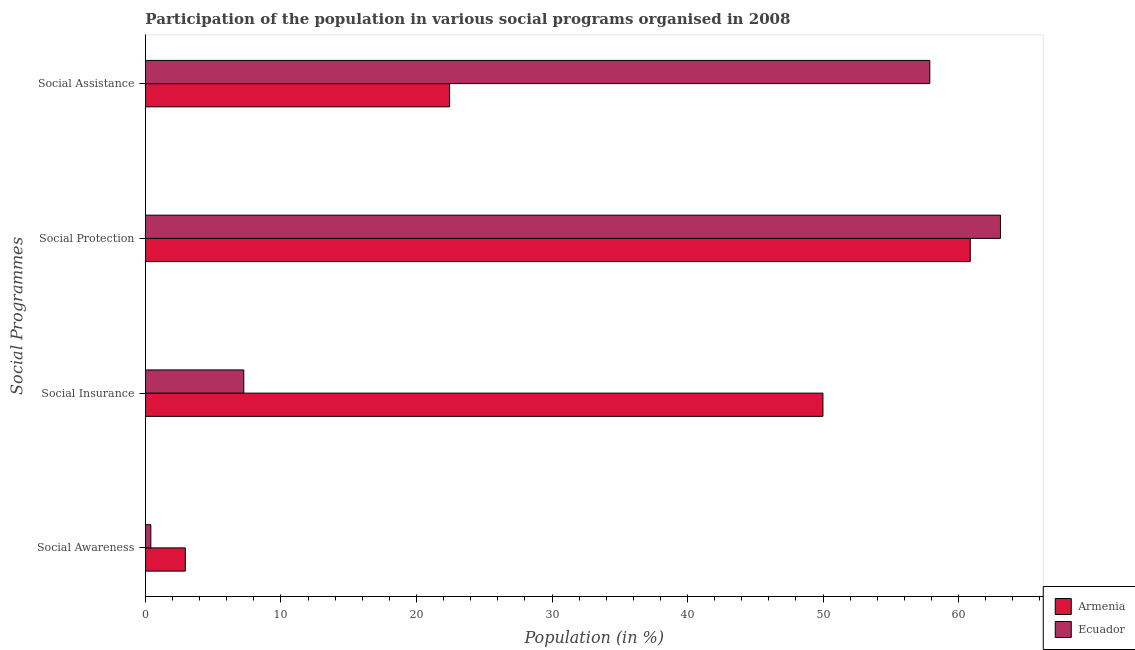Are the number of bars per tick equal to the number of legend labels?
Ensure brevity in your answer.  Yes. Are the number of bars on each tick of the Y-axis equal?
Provide a succinct answer. Yes. How many bars are there on the 1st tick from the top?
Your answer should be compact. 2. What is the label of the 2nd group of bars from the top?
Keep it short and to the point. Social Protection. What is the participation of population in social assistance programs in Ecuador?
Ensure brevity in your answer.  57.88. Across all countries, what is the maximum participation of population in social awareness programs?
Your answer should be very brief. 2.94. Across all countries, what is the minimum participation of population in social protection programs?
Provide a succinct answer. 60.86. In which country was the participation of population in social protection programs maximum?
Provide a succinct answer. Ecuador. In which country was the participation of population in social protection programs minimum?
Provide a short and direct response. Armenia. What is the total participation of population in social awareness programs in the graph?
Offer a terse response. 3.34. What is the difference between the participation of population in social assistance programs in Ecuador and that in Armenia?
Your response must be concise. 35.43. What is the difference between the participation of population in social awareness programs in Ecuador and the participation of population in social assistance programs in Armenia?
Your response must be concise. -22.05. What is the average participation of population in social assistance programs per country?
Your answer should be compact. 40.16. What is the difference between the participation of population in social awareness programs and participation of population in social assistance programs in Ecuador?
Ensure brevity in your answer.  -57.48. In how many countries, is the participation of population in social insurance programs greater than 14 %?
Your answer should be compact. 1. What is the ratio of the participation of population in social protection programs in Armenia to that in Ecuador?
Provide a succinct answer. 0.96. Is the participation of population in social awareness programs in Ecuador less than that in Armenia?
Provide a succinct answer. Yes. Is the difference between the participation of population in social protection programs in Armenia and Ecuador greater than the difference between the participation of population in social awareness programs in Armenia and Ecuador?
Ensure brevity in your answer.  No. What is the difference between the highest and the second highest participation of population in social insurance programs?
Provide a short and direct response. 42.74. What is the difference between the highest and the lowest participation of population in social insurance programs?
Your answer should be compact. 42.74. Is the sum of the participation of population in social awareness programs in Ecuador and Armenia greater than the maximum participation of population in social protection programs across all countries?
Your answer should be very brief. No. Is it the case that in every country, the sum of the participation of population in social insurance programs and participation of population in social protection programs is greater than the sum of participation of population in social assistance programs and participation of population in social awareness programs?
Your answer should be compact. Yes. What does the 2nd bar from the top in Social Insurance represents?
Ensure brevity in your answer.  Armenia. What does the 2nd bar from the bottom in Social Protection represents?
Keep it short and to the point. Ecuador. Is it the case that in every country, the sum of the participation of population in social awareness programs and participation of population in social insurance programs is greater than the participation of population in social protection programs?
Provide a succinct answer. No. How many bars are there?
Ensure brevity in your answer.  8. Are the values on the major ticks of X-axis written in scientific E-notation?
Provide a short and direct response. No. What is the title of the graph?
Offer a terse response. Participation of the population in various social programs organised in 2008. What is the label or title of the Y-axis?
Offer a very short reply. Social Programmes. What is the Population (in %) of Armenia in Social Awareness?
Keep it short and to the point. 2.94. What is the Population (in %) of Ecuador in Social Awareness?
Your answer should be compact. 0.4. What is the Population (in %) in Armenia in Social Insurance?
Give a very brief answer. 49.99. What is the Population (in %) of Ecuador in Social Insurance?
Offer a very short reply. 7.26. What is the Population (in %) of Armenia in Social Protection?
Provide a succinct answer. 60.86. What is the Population (in %) in Ecuador in Social Protection?
Provide a short and direct response. 63.09. What is the Population (in %) of Armenia in Social Assistance?
Offer a very short reply. 22.44. What is the Population (in %) of Ecuador in Social Assistance?
Offer a terse response. 57.88. Across all Social Programmes, what is the maximum Population (in %) in Armenia?
Your response must be concise. 60.86. Across all Social Programmes, what is the maximum Population (in %) of Ecuador?
Make the answer very short. 63.09. Across all Social Programmes, what is the minimum Population (in %) in Armenia?
Give a very brief answer. 2.94. Across all Social Programmes, what is the minimum Population (in %) of Ecuador?
Keep it short and to the point. 0.4. What is the total Population (in %) of Armenia in the graph?
Keep it short and to the point. 136.24. What is the total Population (in %) in Ecuador in the graph?
Make the answer very short. 128.62. What is the difference between the Population (in %) of Armenia in Social Awareness and that in Social Insurance?
Make the answer very short. -47.05. What is the difference between the Population (in %) in Ecuador in Social Awareness and that in Social Insurance?
Your answer should be compact. -6.86. What is the difference between the Population (in %) of Armenia in Social Awareness and that in Social Protection?
Give a very brief answer. -57.92. What is the difference between the Population (in %) of Ecuador in Social Awareness and that in Social Protection?
Make the answer very short. -62.7. What is the difference between the Population (in %) in Armenia in Social Awareness and that in Social Assistance?
Give a very brief answer. -19.5. What is the difference between the Population (in %) of Ecuador in Social Awareness and that in Social Assistance?
Provide a short and direct response. -57.48. What is the difference between the Population (in %) of Armenia in Social Insurance and that in Social Protection?
Your answer should be very brief. -10.87. What is the difference between the Population (in %) in Ecuador in Social Insurance and that in Social Protection?
Offer a terse response. -55.84. What is the difference between the Population (in %) in Armenia in Social Insurance and that in Social Assistance?
Your answer should be compact. 27.55. What is the difference between the Population (in %) in Ecuador in Social Insurance and that in Social Assistance?
Ensure brevity in your answer.  -50.62. What is the difference between the Population (in %) of Armenia in Social Protection and that in Social Assistance?
Your response must be concise. 38.42. What is the difference between the Population (in %) of Ecuador in Social Protection and that in Social Assistance?
Your answer should be very brief. 5.22. What is the difference between the Population (in %) in Armenia in Social Awareness and the Population (in %) in Ecuador in Social Insurance?
Make the answer very short. -4.31. What is the difference between the Population (in %) in Armenia in Social Awareness and the Population (in %) in Ecuador in Social Protection?
Offer a terse response. -60.15. What is the difference between the Population (in %) in Armenia in Social Awareness and the Population (in %) in Ecuador in Social Assistance?
Your answer should be very brief. -54.94. What is the difference between the Population (in %) of Armenia in Social Insurance and the Population (in %) of Ecuador in Social Protection?
Give a very brief answer. -13.1. What is the difference between the Population (in %) in Armenia in Social Insurance and the Population (in %) in Ecuador in Social Assistance?
Keep it short and to the point. -7.89. What is the difference between the Population (in %) of Armenia in Social Protection and the Population (in %) of Ecuador in Social Assistance?
Give a very brief answer. 2.99. What is the average Population (in %) of Armenia per Social Programmes?
Provide a short and direct response. 34.06. What is the average Population (in %) of Ecuador per Social Programmes?
Give a very brief answer. 32.16. What is the difference between the Population (in %) in Armenia and Population (in %) in Ecuador in Social Awareness?
Offer a terse response. 2.54. What is the difference between the Population (in %) of Armenia and Population (in %) of Ecuador in Social Insurance?
Keep it short and to the point. 42.74. What is the difference between the Population (in %) of Armenia and Population (in %) of Ecuador in Social Protection?
Offer a very short reply. -2.23. What is the difference between the Population (in %) of Armenia and Population (in %) of Ecuador in Social Assistance?
Provide a short and direct response. -35.43. What is the ratio of the Population (in %) in Armenia in Social Awareness to that in Social Insurance?
Offer a terse response. 0.06. What is the ratio of the Population (in %) of Ecuador in Social Awareness to that in Social Insurance?
Provide a succinct answer. 0.05. What is the ratio of the Population (in %) in Armenia in Social Awareness to that in Social Protection?
Provide a short and direct response. 0.05. What is the ratio of the Population (in %) of Ecuador in Social Awareness to that in Social Protection?
Make the answer very short. 0.01. What is the ratio of the Population (in %) of Armenia in Social Awareness to that in Social Assistance?
Make the answer very short. 0.13. What is the ratio of the Population (in %) in Ecuador in Social Awareness to that in Social Assistance?
Ensure brevity in your answer.  0.01. What is the ratio of the Population (in %) in Armenia in Social Insurance to that in Social Protection?
Provide a short and direct response. 0.82. What is the ratio of the Population (in %) of Ecuador in Social Insurance to that in Social Protection?
Offer a very short reply. 0.12. What is the ratio of the Population (in %) in Armenia in Social Insurance to that in Social Assistance?
Keep it short and to the point. 2.23. What is the ratio of the Population (in %) of Ecuador in Social Insurance to that in Social Assistance?
Keep it short and to the point. 0.13. What is the ratio of the Population (in %) in Armenia in Social Protection to that in Social Assistance?
Provide a short and direct response. 2.71. What is the ratio of the Population (in %) of Ecuador in Social Protection to that in Social Assistance?
Offer a terse response. 1.09. What is the difference between the highest and the second highest Population (in %) in Armenia?
Provide a succinct answer. 10.87. What is the difference between the highest and the second highest Population (in %) of Ecuador?
Ensure brevity in your answer.  5.22. What is the difference between the highest and the lowest Population (in %) of Armenia?
Ensure brevity in your answer.  57.92. What is the difference between the highest and the lowest Population (in %) in Ecuador?
Make the answer very short. 62.7. 